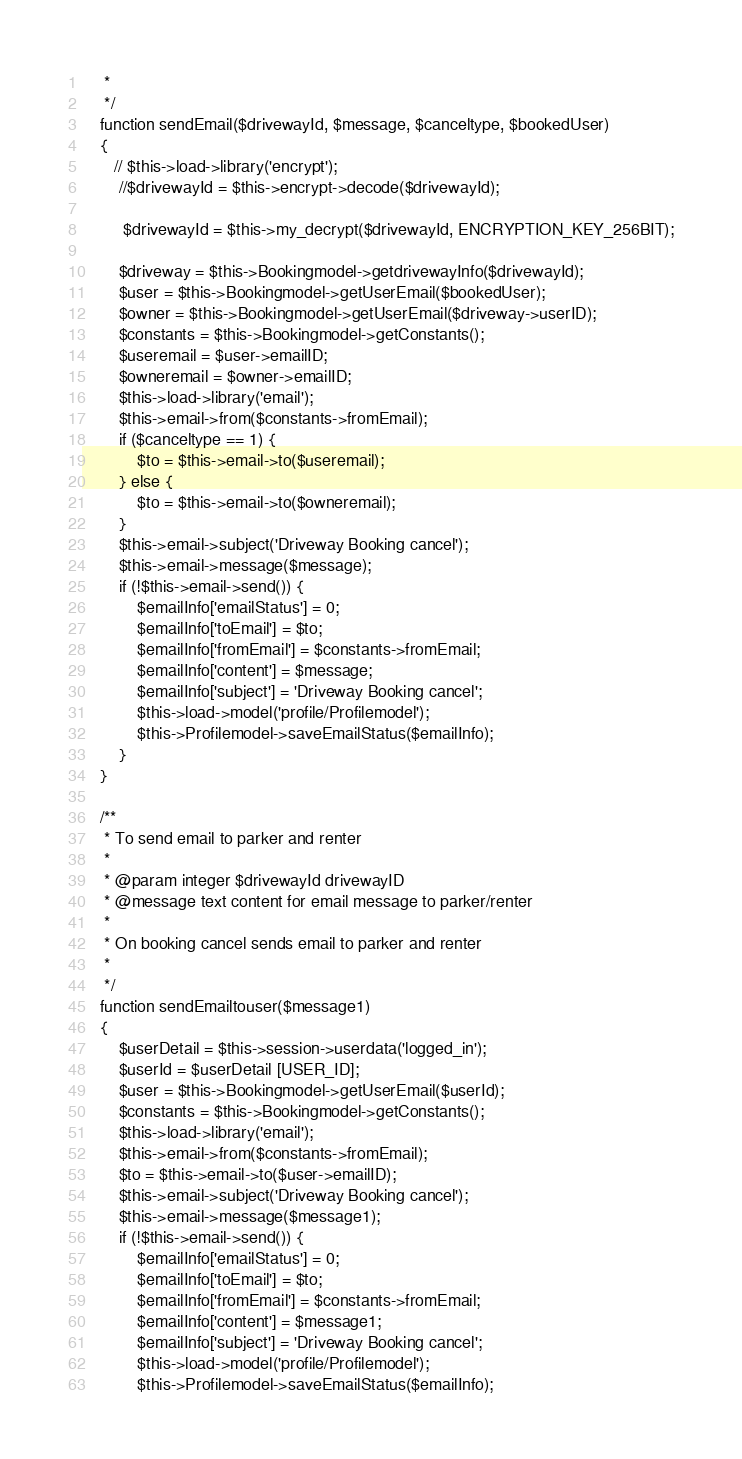<code> <loc_0><loc_0><loc_500><loc_500><_PHP_>     *     
     */
    function sendEmail($drivewayId, $message, $canceltype, $bookedUser)
    {
       // $this->load->library('encrypt');
        //$drivewayId = $this->encrypt->decode($drivewayId);
        
         $drivewayId = $this->my_decrypt($drivewayId, ENCRYPTION_KEY_256BIT);
         
        $driveway = $this->Bookingmodel->getdrivewayInfo($drivewayId);
        $user = $this->Bookingmodel->getUserEmail($bookedUser);
        $owner = $this->Bookingmodel->getUserEmail($driveway->userID);
        $constants = $this->Bookingmodel->getConstants();
        $useremail = $user->emailID;
        $owneremail = $owner->emailID;
        $this->load->library('email');
        $this->email->from($constants->fromEmail);
        if ($canceltype == 1) {
            $to = $this->email->to($useremail);
        } else {
            $to = $this->email->to($owneremail);
        }
        $this->email->subject('Driveway Booking cancel');
        $this->email->message($message);
        if (!$this->email->send()) {
            $emailInfo['emailStatus'] = 0;
            $emailInfo['toEmail'] = $to;
            $emailInfo['fromEmail'] = $constants->fromEmail;
            $emailInfo['content'] = $message;
            $emailInfo['subject'] = 'Driveway Booking cancel';
            $this->load->model('profile/Profilemodel');
            $this->Profilemodel->saveEmailStatus($emailInfo);
        }
    }

    /**
     * To send email to parker and renter
     * 
     * @param integer $drivewayId drivewayID
     * @message text content for email message to parker/renter
     * 
     * On booking cancel sends email to parker and renter
     *     
     */
    function sendEmailtouser($message1)
    {
        $userDetail = $this->session->userdata('logged_in');
        $userId = $userDetail [USER_ID];
        $user = $this->Bookingmodel->getUserEmail($userId);
        $constants = $this->Bookingmodel->getConstants();
        $this->load->library('email');
        $this->email->from($constants->fromEmail);
        $to = $this->email->to($user->emailID);
        $this->email->subject('Driveway Booking cancel');
        $this->email->message($message1);
        if (!$this->email->send()) {
            $emailInfo['emailStatus'] = 0;
            $emailInfo['toEmail'] = $to;
            $emailInfo['fromEmail'] = $constants->fromEmail;
            $emailInfo['content'] = $message1;
            $emailInfo['subject'] = 'Driveway Booking cancel';
            $this->load->model('profile/Profilemodel');
            $this->Profilemodel->saveEmailStatus($emailInfo);</code> 